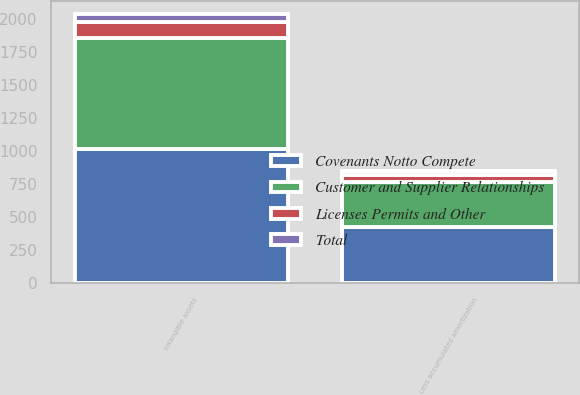<chart> <loc_0><loc_0><loc_500><loc_500><stacked_bar_chart><ecel><fcel>Intangible assets<fcel>Less accumulated amortization<nl><fcel>Customer and Supplier Relationships<fcel>835<fcel>342<nl><fcel>Total<fcel>59<fcel>31<nl><fcel>Licenses Permits and Other<fcel>123<fcel>53<nl><fcel>Covenants Notto Compete<fcel>1017<fcel>426<nl></chart> 